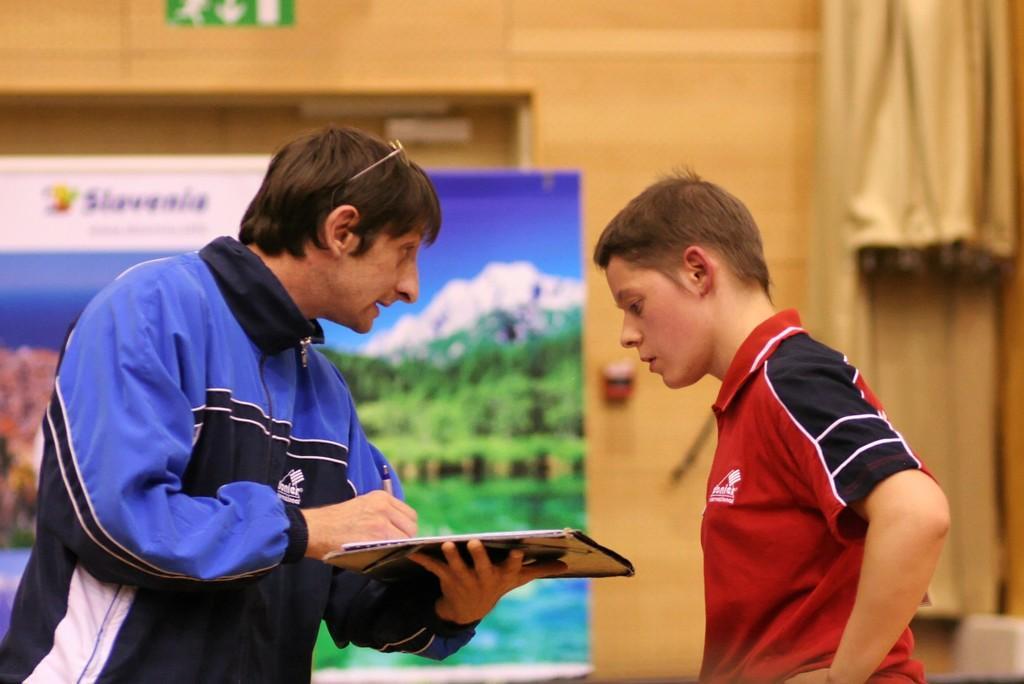Please provide a concise description of this image. In this image in the foreground there is person holding a pad, there is a boy visible in front of him, behind them there is the wall, in front of the wall there is the board and a curtain visible on the right side. 